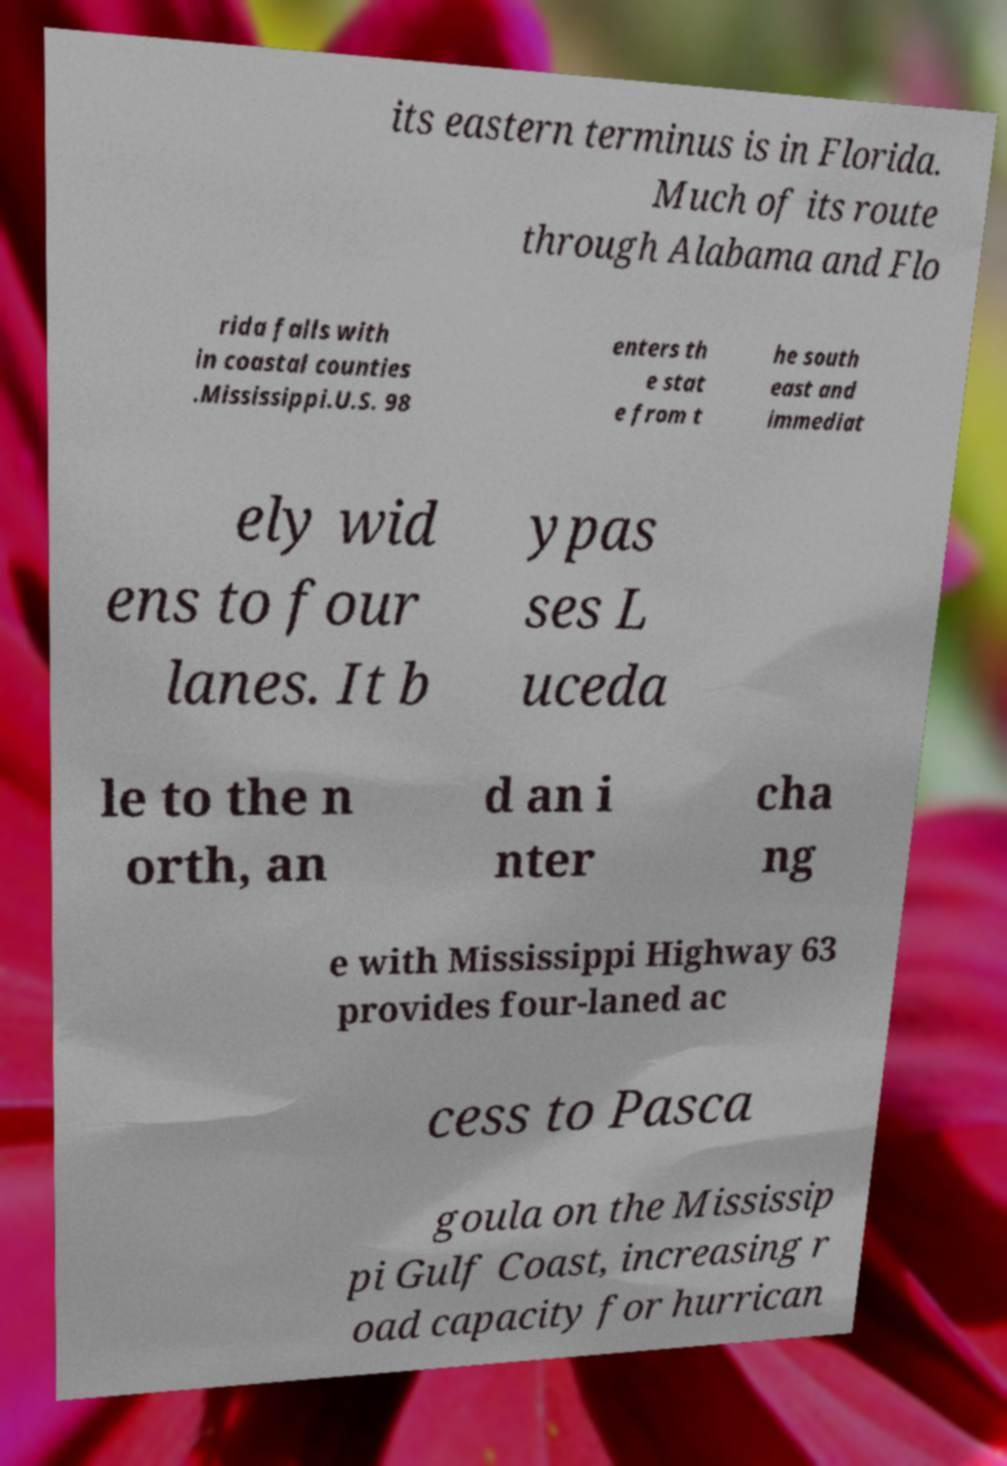I need the written content from this picture converted into text. Can you do that? its eastern terminus is in Florida. Much of its route through Alabama and Flo rida falls with in coastal counties .Mississippi.U.S. 98 enters th e stat e from t he south east and immediat ely wid ens to four lanes. It b ypas ses L uceda le to the n orth, an d an i nter cha ng e with Mississippi Highway 63 provides four-laned ac cess to Pasca goula on the Mississip pi Gulf Coast, increasing r oad capacity for hurrican 